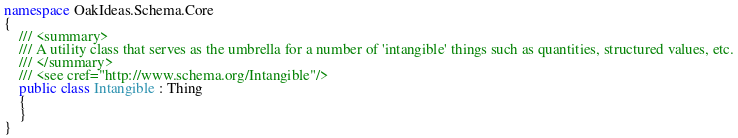<code> <loc_0><loc_0><loc_500><loc_500><_C#_>namespace OakIdeas.Schema.Core
{
    /// <summary>
    /// A utility class that serves as the umbrella for a number of 'intangible' things such as quantities, structured values, etc.
    /// </summary>
    /// <see cref="http://www.schema.org/Intangible"/>
    public class Intangible : Thing
    {
    }
}
</code> 